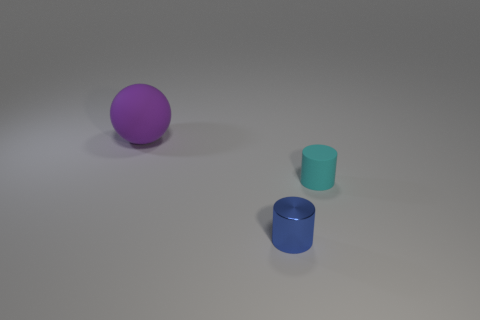Add 1 tiny blue things. How many objects exist? 4 Subtract all spheres. How many objects are left? 2 Add 3 small cyan objects. How many small cyan objects are left? 4 Add 1 small gray matte spheres. How many small gray matte spheres exist? 1 Subtract 0 cyan balls. How many objects are left? 3 Subtract all purple shiny objects. Subtract all blue metallic cylinders. How many objects are left? 2 